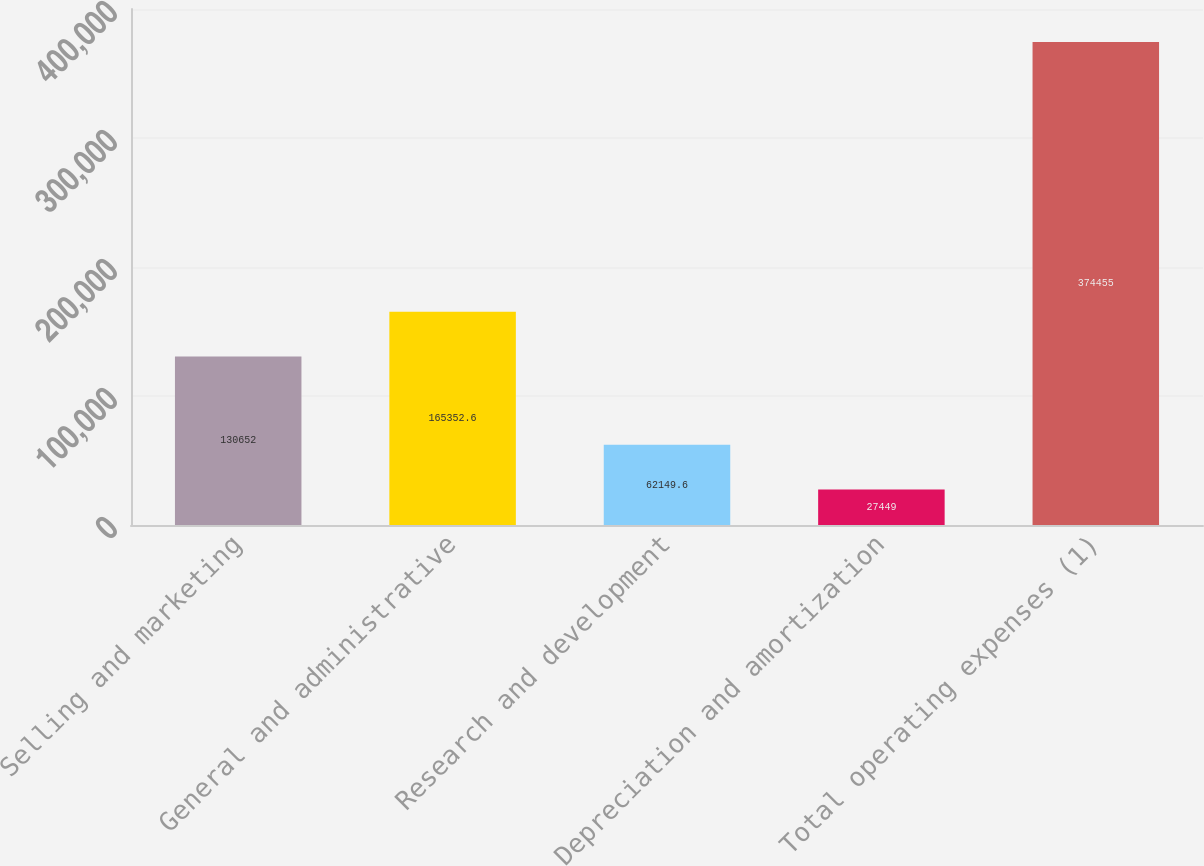Convert chart to OTSL. <chart><loc_0><loc_0><loc_500><loc_500><bar_chart><fcel>Selling and marketing<fcel>General and administrative<fcel>Research and development<fcel>Depreciation and amortization<fcel>Total operating expenses (1)<nl><fcel>130652<fcel>165353<fcel>62149.6<fcel>27449<fcel>374455<nl></chart> 